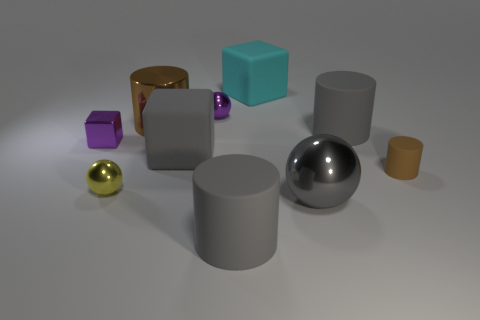Are any big yellow metallic things visible?
Give a very brief answer. No. There is a thing that is both to the left of the big metal cylinder and behind the tiny brown thing; how big is it?
Ensure brevity in your answer.  Small. Are there more purple metal things left of the large metal cylinder than metal objects that are in front of the metallic cube?
Give a very brief answer. No. What size is the metal sphere that is the same color as the tiny block?
Provide a succinct answer. Small. The large metal ball is what color?
Ensure brevity in your answer.  Gray. There is a cylinder that is both on the left side of the tiny brown object and in front of the gray rubber cube; what color is it?
Your response must be concise. Gray. The rubber cylinder in front of the brown cylinder that is to the right of the big block behind the purple metallic sphere is what color?
Your response must be concise. Gray. There is a cylinder that is the same size as the purple cube; what is its color?
Provide a succinct answer. Brown. There is a large matte thing that is behind the shiny sphere behind the brown object to the right of the big shiny cylinder; what shape is it?
Your response must be concise. Cube. There is a rubber thing that is the same color as the shiny cylinder; what is its shape?
Your answer should be compact. Cylinder. 